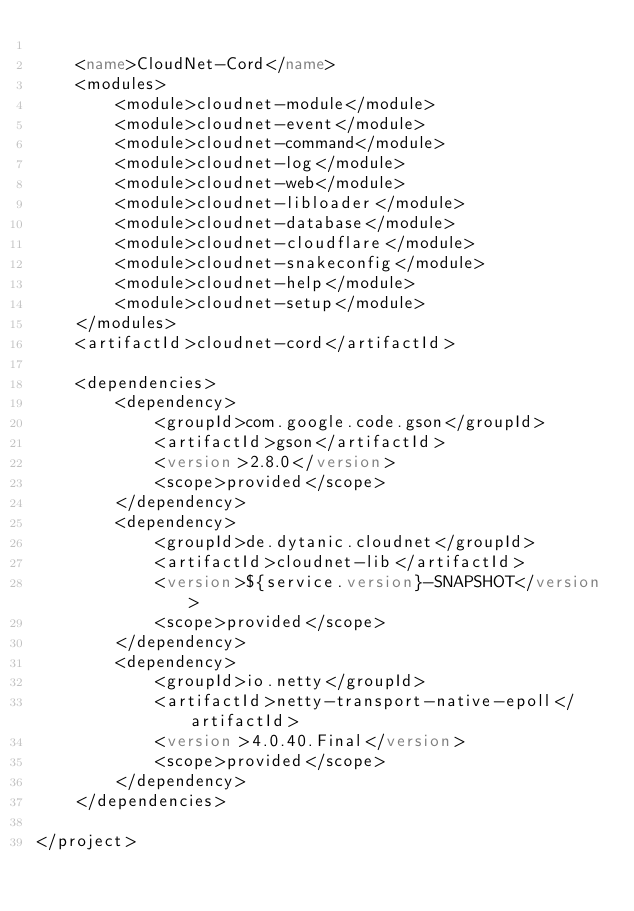Convert code to text. <code><loc_0><loc_0><loc_500><loc_500><_XML_>
    <name>CloudNet-Cord</name>
    <modules>
        <module>cloudnet-module</module>
        <module>cloudnet-event</module>
        <module>cloudnet-command</module>
        <module>cloudnet-log</module>
        <module>cloudnet-web</module>
        <module>cloudnet-libloader</module>
        <module>cloudnet-database</module>
        <module>cloudnet-cloudflare</module>
        <module>cloudnet-snakeconfig</module>
        <module>cloudnet-help</module>
        <module>cloudnet-setup</module>
    </modules>
    <artifactId>cloudnet-cord</artifactId>

    <dependencies>
        <dependency>
            <groupId>com.google.code.gson</groupId>
            <artifactId>gson</artifactId>
            <version>2.8.0</version>
            <scope>provided</scope>
        </dependency>
        <dependency>
            <groupId>de.dytanic.cloudnet</groupId>
            <artifactId>cloudnet-lib</artifactId>
            <version>${service.version}-SNAPSHOT</version>
            <scope>provided</scope>
        </dependency>
        <dependency>
            <groupId>io.netty</groupId>
            <artifactId>netty-transport-native-epoll</artifactId>
            <version>4.0.40.Final</version>
            <scope>provided</scope>
        </dependency>
    </dependencies>

</project></code> 